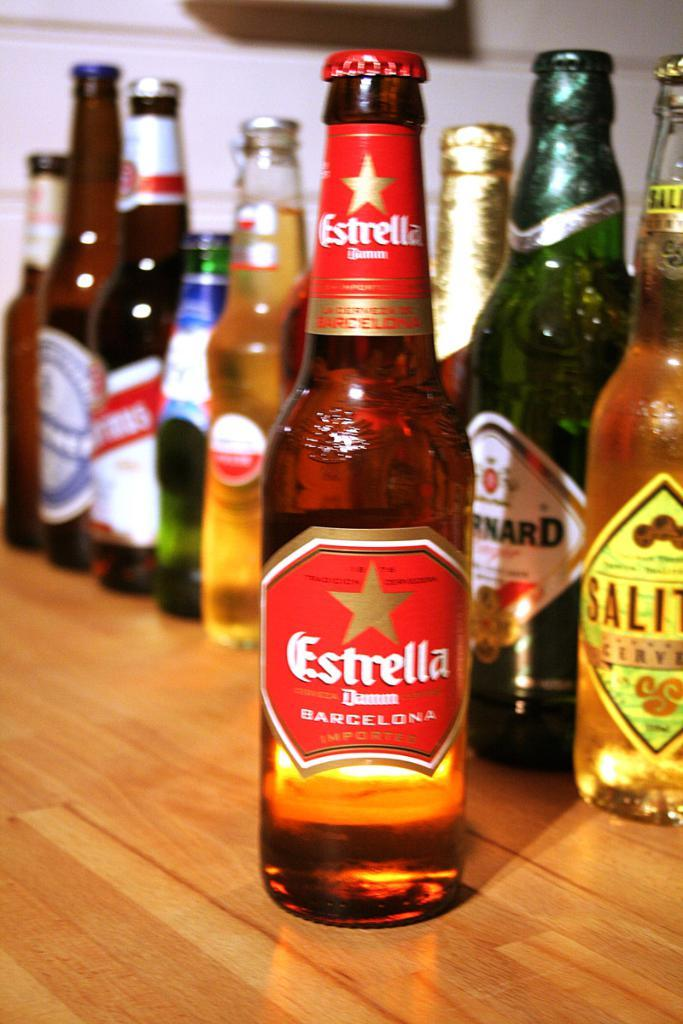<image>
Provide a brief description of the given image. Many bottles of beer are arranged including one named Estrella. 